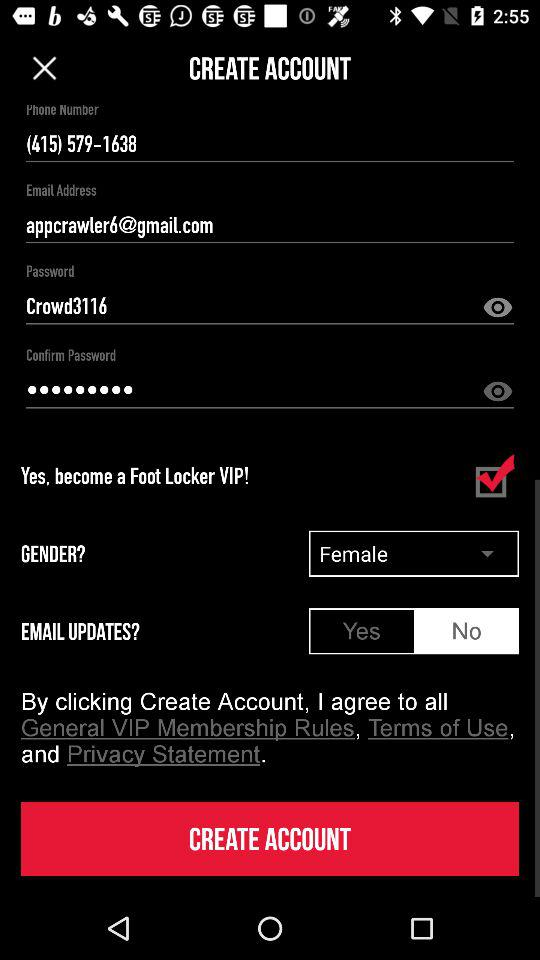What email address is used? The used email address is appcrawler6@gmail.com. 